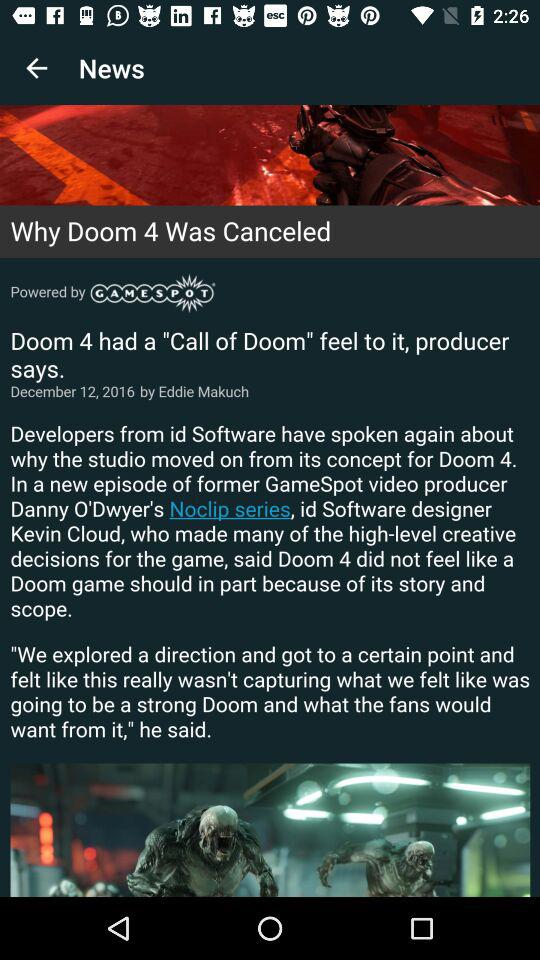Who is the author of the article? The author of the article is Eddie Makuch. 